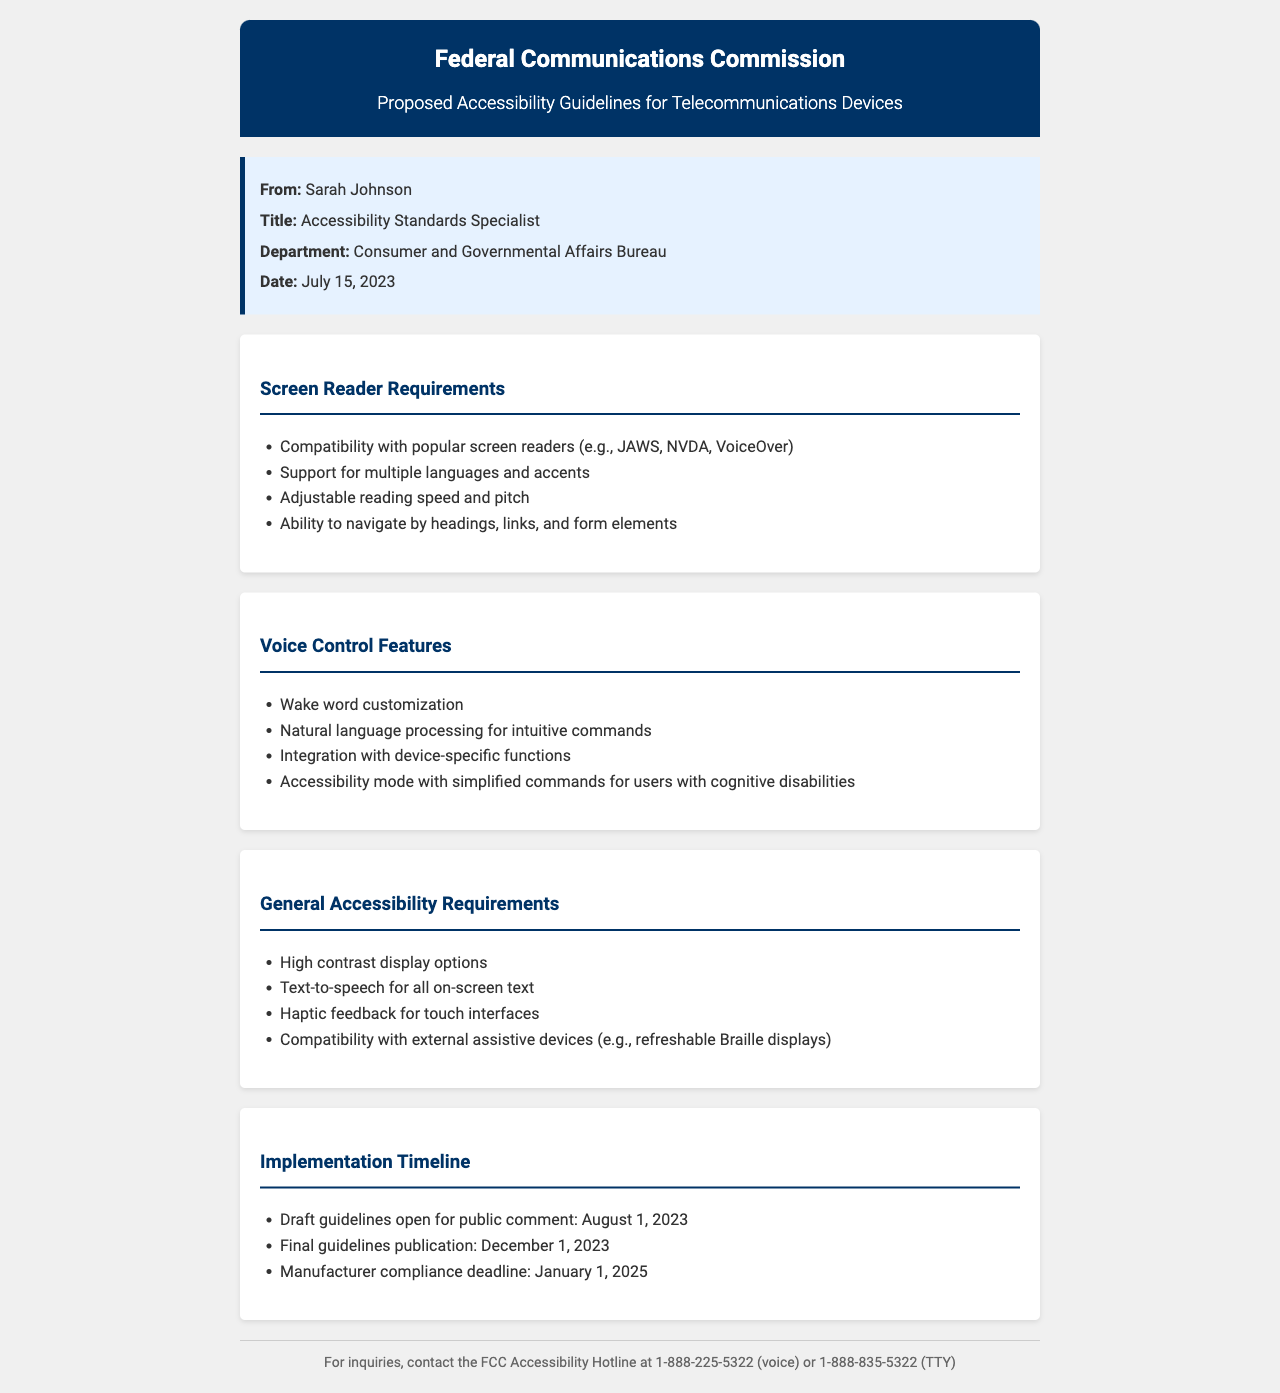What is the title of the document? The title of the document is stated in the header section, reflecting the purpose and content of the guidelines.
Answer: Proposed Accessibility Guidelines for Telecommunications Devices Who is the sender of the document? The sender's name is provided in the sender information section of the document.
Answer: Sarah Johnson What is the publication date for the final guidelines? The date for final guidelines publication is listed in the implementation timeline section of the document.
Answer: December 1, 2023 What are the main requirements for screen readers? The requirements for screen readers are enumerated in the specific section dedicated to them in the document.
Answer: Compatibility with popular screen readers What is one feature mentioned for voice control? The voice control features are detailed in their own section, outlining various functionalities.
Answer: Wake word customization What is the compliance deadline for manufacturers? The compliance deadline is indicated in the implementation timeline section for manufacturers to adhere to the guidelines.
Answer: January 1, 2025 How many languages should screen readers support? The document notes the importance of supporting multiple languages and accents in the screen reader requirements section.
Answer: Multiple languages What type of feedback is required for touch interfaces? The requirement for touch interfaces is specified in the general accessibility requirements section.
Answer: Haptic feedback What is the contact number for the FCC Accessibility Hotline? The contact information is provided at the end of the document for inquiries, specifying the hotline number.
Answer: 1-888-225-5322 